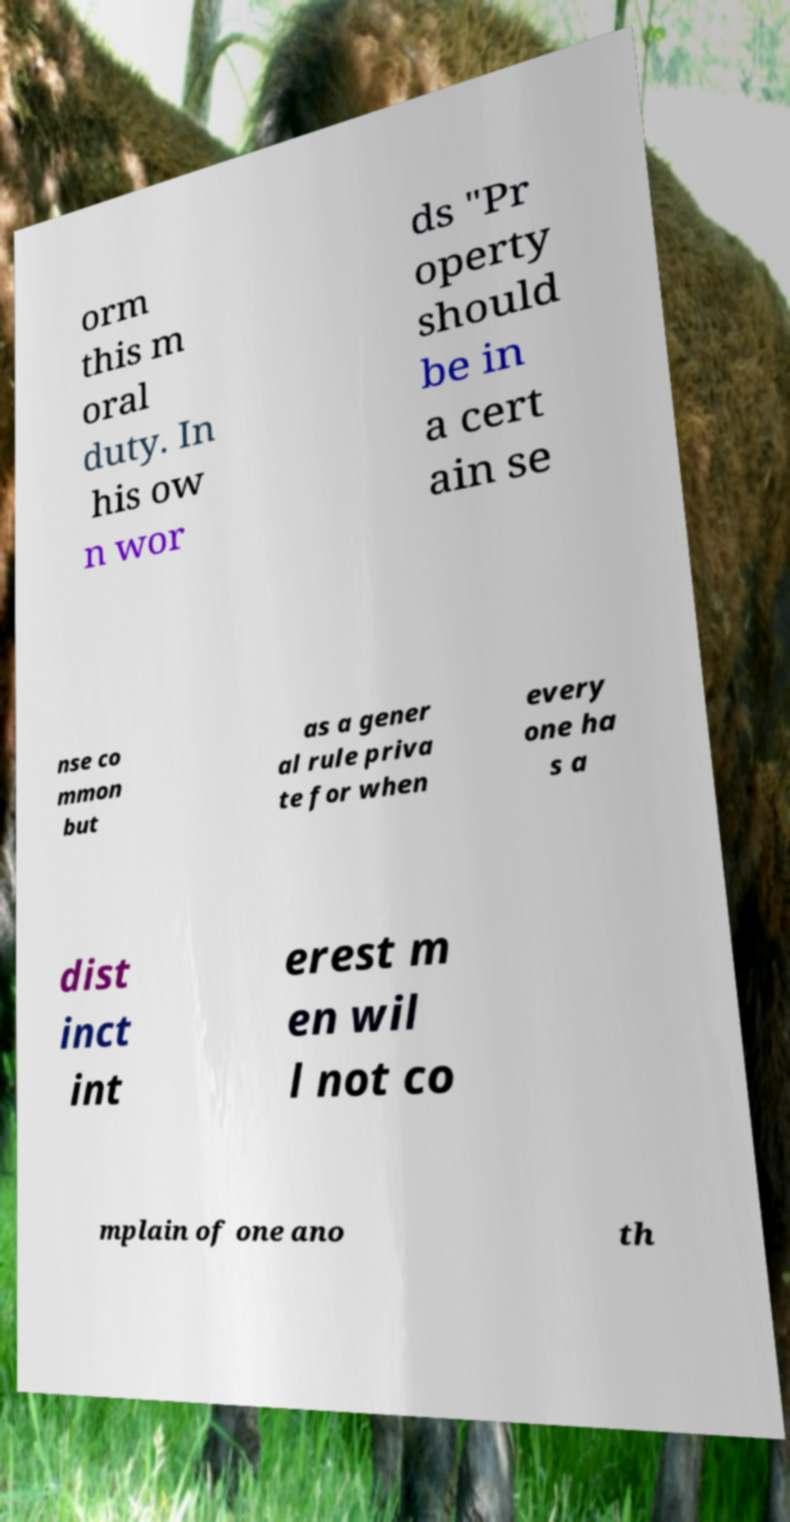Can you read and provide the text displayed in the image?This photo seems to have some interesting text. Can you extract and type it out for me? orm this m oral duty. In his ow n wor ds "Pr operty should be in a cert ain se nse co mmon but as a gener al rule priva te for when every one ha s a dist inct int erest m en wil l not co mplain of one ano th 